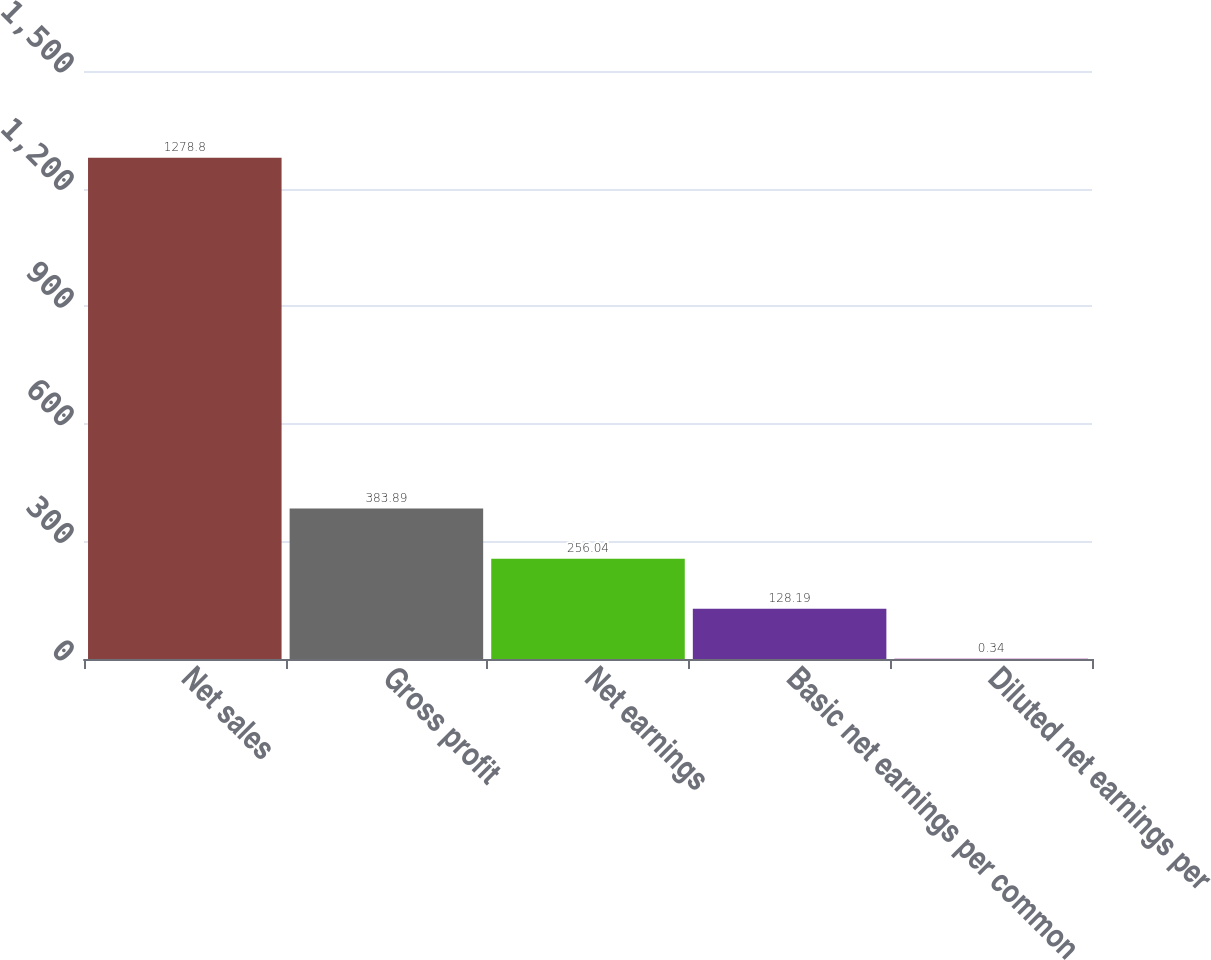Convert chart. <chart><loc_0><loc_0><loc_500><loc_500><bar_chart><fcel>Net sales<fcel>Gross profit<fcel>Net earnings<fcel>Basic net earnings per common<fcel>Diluted net earnings per<nl><fcel>1278.8<fcel>383.89<fcel>256.04<fcel>128.19<fcel>0.34<nl></chart> 